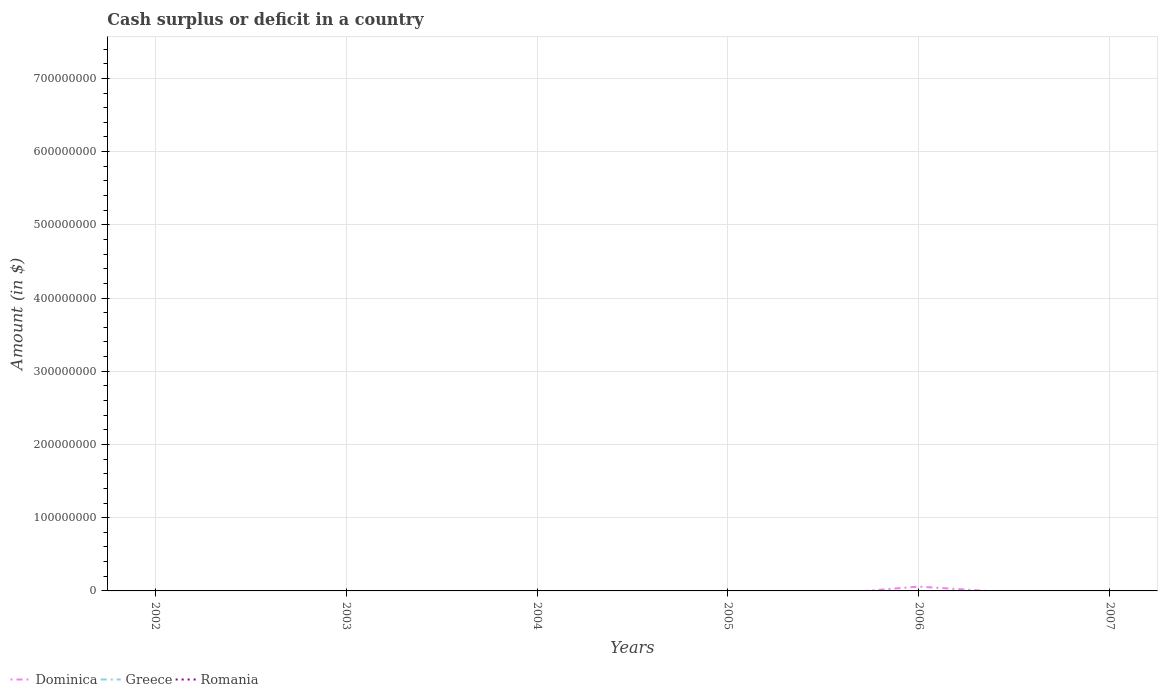Does the line corresponding to Romania intersect with the line corresponding to Dominica?
Offer a very short reply. No. Is the number of lines equal to the number of legend labels?
Provide a short and direct response. No. Across all years, what is the maximum amount of cash surplus or deficit in Dominica?
Provide a succinct answer. 0. What is the difference between the highest and the second highest amount of cash surplus or deficit in Dominica?
Keep it short and to the point. 5.90e+06. What is the difference between the highest and the lowest amount of cash surplus or deficit in Dominica?
Provide a succinct answer. 1. How many years are there in the graph?
Give a very brief answer. 6. What is the difference between two consecutive major ticks on the Y-axis?
Provide a short and direct response. 1.00e+08. Are the values on the major ticks of Y-axis written in scientific E-notation?
Your answer should be compact. No. Does the graph contain any zero values?
Your answer should be compact. Yes. How many legend labels are there?
Your answer should be compact. 3. What is the title of the graph?
Your response must be concise. Cash surplus or deficit in a country. What is the label or title of the Y-axis?
Your answer should be very brief. Amount (in $). What is the Amount (in $) of Romania in 2002?
Offer a terse response. 0. What is the Amount (in $) of Dominica in 2003?
Keep it short and to the point. 0. What is the Amount (in $) in Romania in 2003?
Your answer should be compact. 0. What is the Amount (in $) of Dominica in 2004?
Your answer should be very brief. 0. What is the Amount (in $) of Dominica in 2005?
Provide a succinct answer. 0. What is the Amount (in $) of Romania in 2005?
Ensure brevity in your answer.  0. What is the Amount (in $) in Dominica in 2006?
Provide a succinct answer. 5.90e+06. What is the Amount (in $) in Greece in 2006?
Your response must be concise. 0. What is the Amount (in $) of Dominica in 2007?
Give a very brief answer. 0. What is the Amount (in $) in Greece in 2007?
Provide a short and direct response. 0. Across all years, what is the maximum Amount (in $) of Dominica?
Your answer should be very brief. 5.90e+06. What is the total Amount (in $) in Dominica in the graph?
Offer a terse response. 5.90e+06. What is the total Amount (in $) of Greece in the graph?
Offer a very short reply. 0. What is the total Amount (in $) of Romania in the graph?
Offer a terse response. 0. What is the average Amount (in $) of Dominica per year?
Your answer should be compact. 9.83e+05. What is the average Amount (in $) of Romania per year?
Your answer should be compact. 0. What is the difference between the highest and the lowest Amount (in $) in Dominica?
Keep it short and to the point. 5.90e+06. 